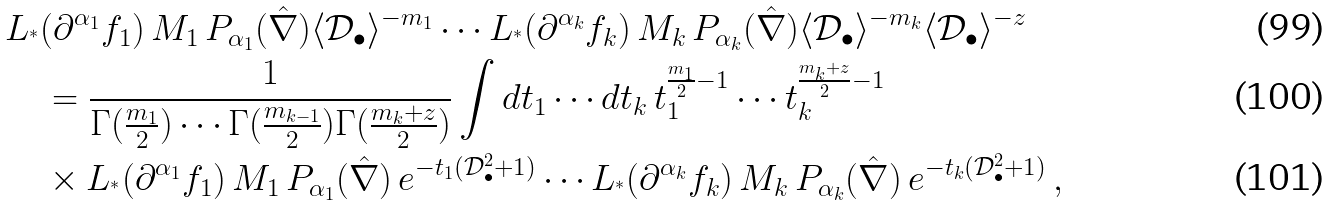<formula> <loc_0><loc_0><loc_500><loc_500>& L _ { ^ { * } } ( \partial ^ { \alpha _ { 1 } } f _ { 1 } ) \, M _ { 1 } \, P _ { \alpha _ { 1 } } ( \hat { \nabla } ) \langle \mathcal { D } _ { \bullet } \rangle ^ { - m _ { 1 } } \cdots L _ { ^ { * } } ( \partial ^ { \alpha _ { k } } f _ { k } ) \, M _ { k } \, P _ { \alpha _ { k } } ( \hat { \nabla } ) \langle \mathcal { D } _ { \bullet } \rangle ^ { - m _ { k } } \langle \mathcal { D } _ { \bullet } \rangle ^ { - z } \\ & \quad = \frac { 1 } { \Gamma ( \frac { m _ { 1 } } { 2 } ) \cdots \Gamma ( \frac { m _ { k - 1 } } { 2 } ) \Gamma ( \frac { m _ { k } + z } { 2 } ) } \int d t _ { 1 } \cdots d t _ { k } \, t _ { 1 } ^ { \frac { m _ { 1 } } { 2 } - 1 } \cdots t _ { k } ^ { \frac { m _ { k } + z } { 2 } - 1 } \, \\ & \quad \times L _ { ^ { * } } ( \partial ^ { \alpha _ { 1 } } f _ { 1 } ) \, M _ { 1 } \, P _ { \alpha _ { 1 } } ( \hat { \nabla } ) \, e ^ { - t _ { 1 } ( \mathcal { D } _ { \bullet } ^ { 2 } + 1 ) } \cdots L _ { ^ { * } } ( \partial ^ { \alpha _ { k } } f _ { k } ) \, M _ { k } \, P _ { \alpha _ { k } } ( \hat { \nabla } ) \, e ^ { - t _ { k } ( \mathcal { D } _ { \bullet } ^ { 2 } + 1 ) } \, ,</formula> 